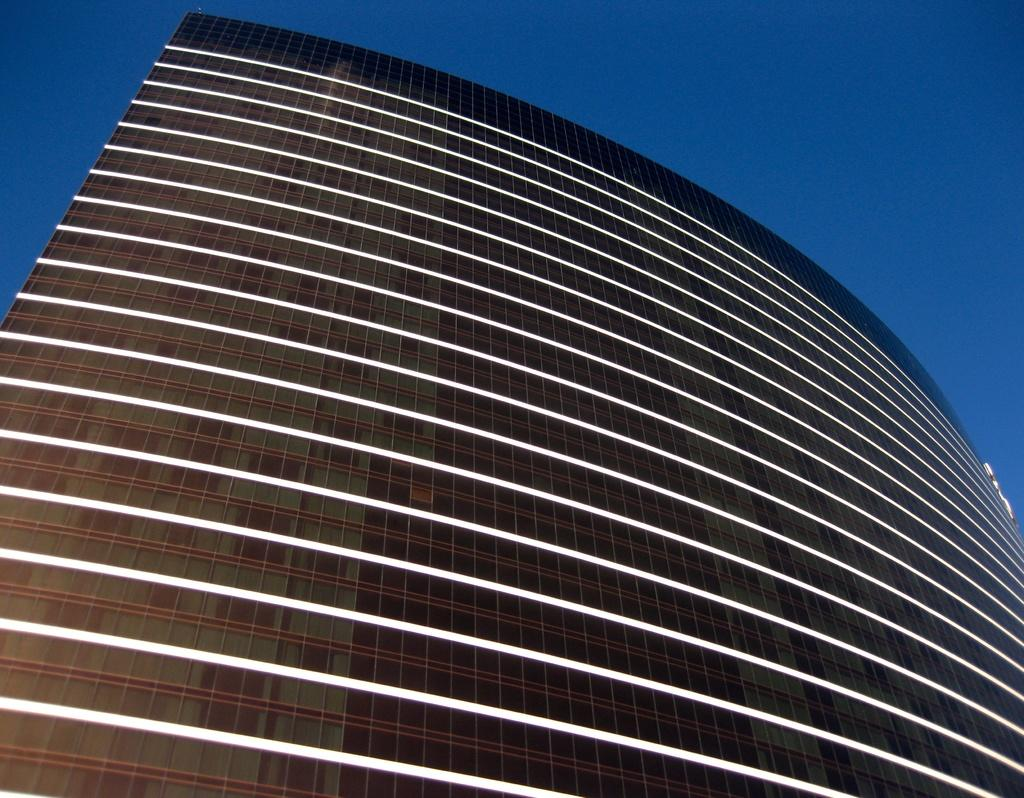What is the main structure visible in the image? There is a building in the front of the image. What part of the natural environment can be seen in the image? The sky is visible in the background of the image. What type of hammer is being used to cause a leak in the building in the image? There is no hammer or leak present in the image; it only features a building and the sky. 